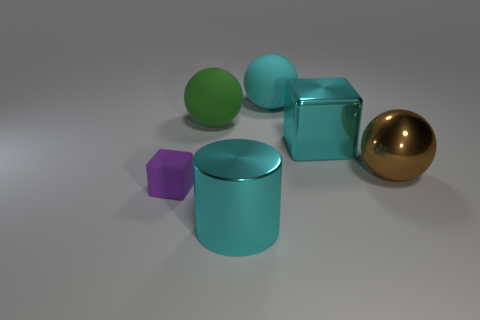What size is the matte object in front of the big brown metal object?
Your response must be concise. Small. How many cylinders are the same color as the big shiny ball?
Keep it short and to the point. 0. There is a cube that is to the left of the big metal cylinder; is there a tiny purple object that is right of it?
Make the answer very short. No. Does the big metallic thing that is left of the metallic block have the same color as the large sphere right of the large cyan metallic block?
Offer a very short reply. No. There is a shiny sphere that is the same size as the cyan cube; what color is it?
Provide a short and direct response. Brown. Are there an equal number of brown objects that are behind the green rubber thing and large objects right of the large cylinder?
Your response must be concise. No. The cyan thing that is on the right side of the big thing that is behind the green rubber ball is made of what material?
Your answer should be compact. Metal. How many things are big purple shiny blocks or brown metal balls?
Keep it short and to the point. 1. What is the size of the ball that is the same color as the big cylinder?
Your answer should be compact. Large. Are there fewer tiny cyan cubes than small purple rubber blocks?
Make the answer very short. Yes. 